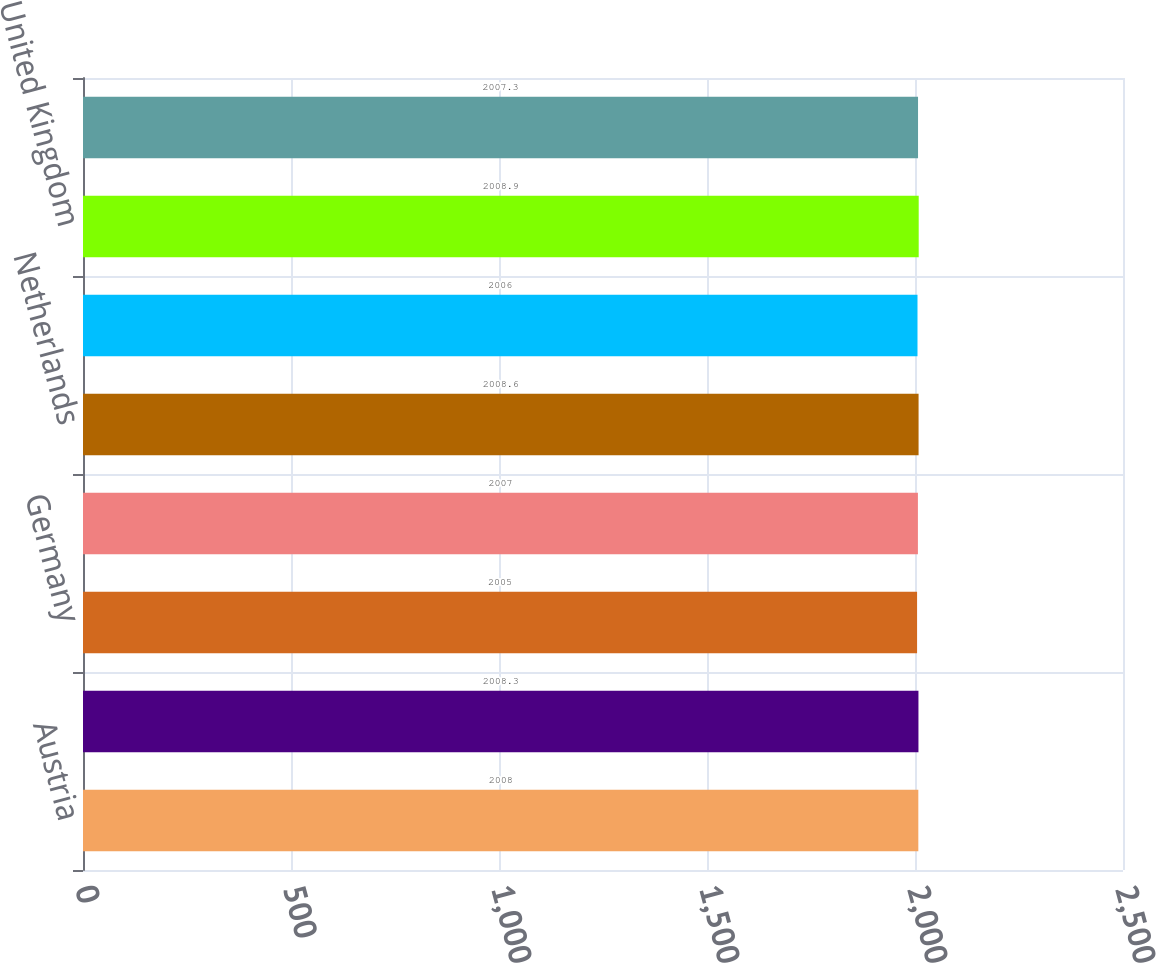Convert chart to OTSL. <chart><loc_0><loc_0><loc_500><loc_500><bar_chart><fcel>Austria<fcel>Canada<fcel>Germany<fcel>Italy<fcel>Netherlands<fcel>Sweden<fcel>United Kingdom<fcel>United States<nl><fcel>2008<fcel>2008.3<fcel>2005<fcel>2007<fcel>2008.6<fcel>2006<fcel>2008.9<fcel>2007.3<nl></chart> 